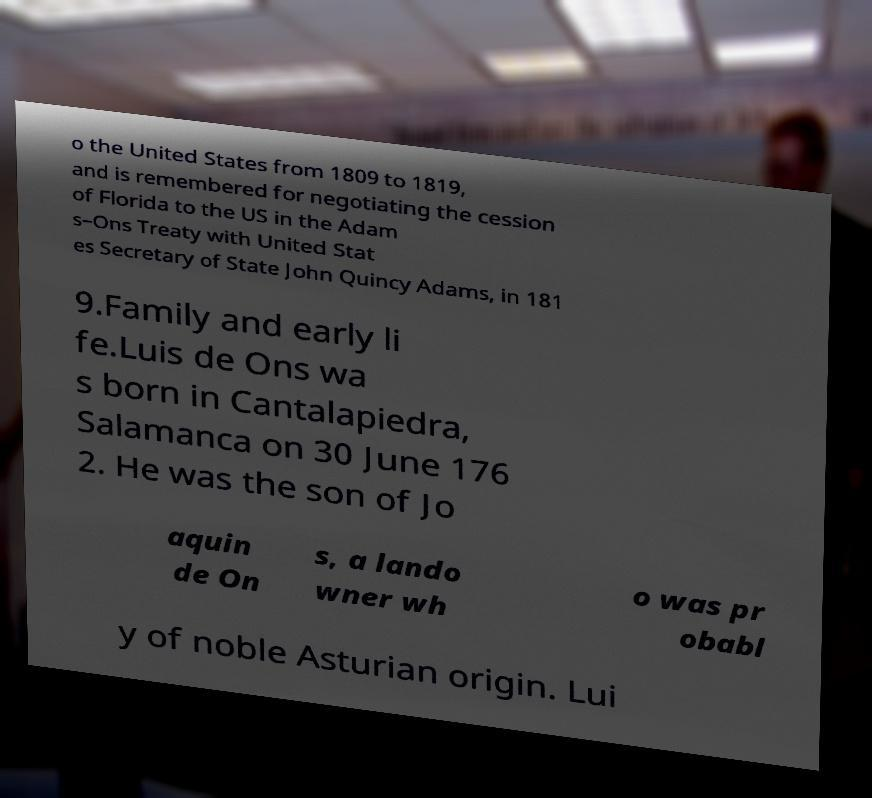Could you assist in decoding the text presented in this image and type it out clearly? o the United States from 1809 to 1819, and is remembered for negotiating the cession of Florida to the US in the Adam s–Ons Treaty with United Stat es Secretary of State John Quincy Adams, in 181 9.Family and early li fe.Luis de Ons wa s born in Cantalapiedra, Salamanca on 30 June 176 2. He was the son of Jo aquin de On s, a lando wner wh o was pr obabl y of noble Asturian origin. Lui 